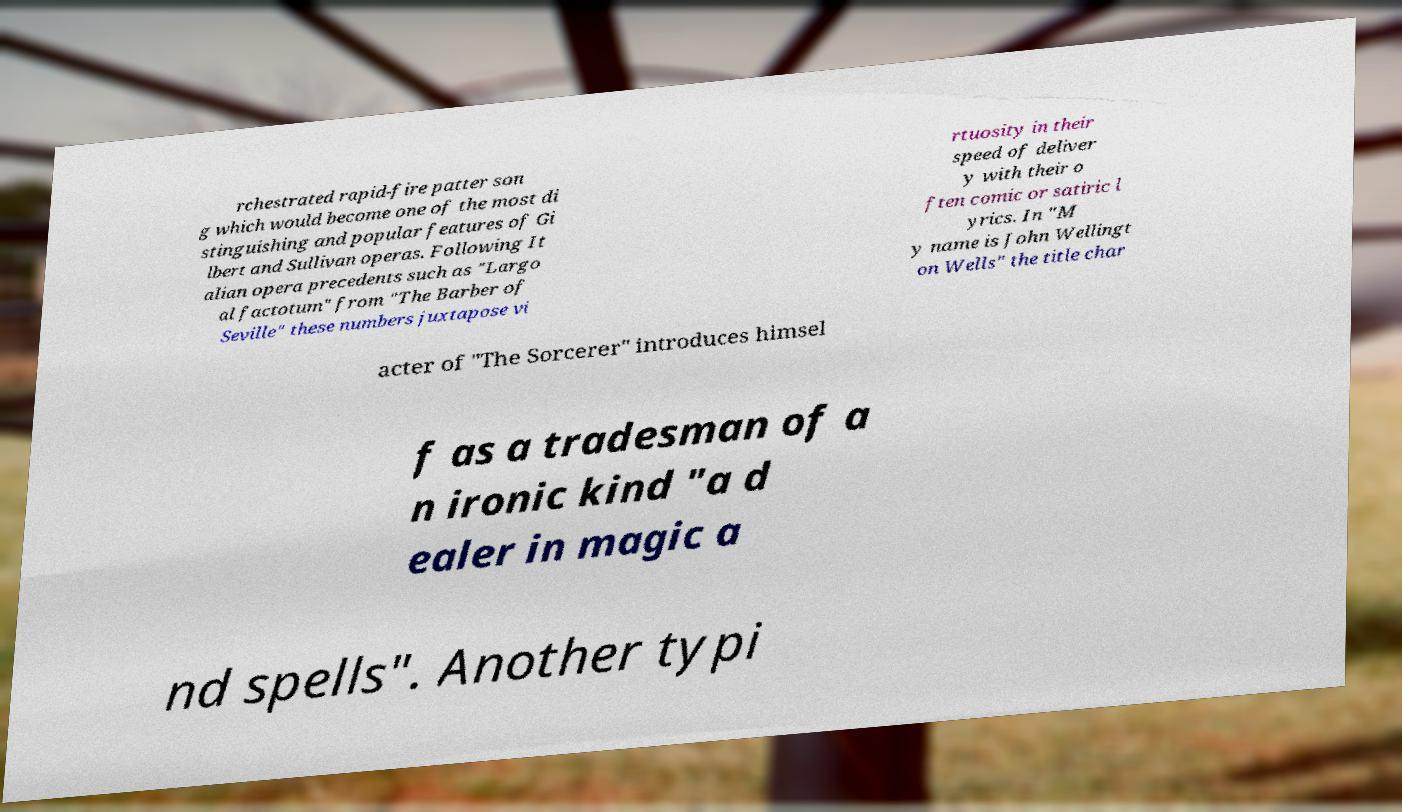Please read and relay the text visible in this image. What does it say? rchestrated rapid-fire patter son g which would become one of the most di stinguishing and popular features of Gi lbert and Sullivan operas. Following It alian opera precedents such as "Largo al factotum" from "The Barber of Seville" these numbers juxtapose vi rtuosity in their speed of deliver y with their o ften comic or satiric l yrics. In "M y name is John Wellingt on Wells" the title char acter of "The Sorcerer" introduces himsel f as a tradesman of a n ironic kind "a d ealer in magic a nd spells". Another typi 